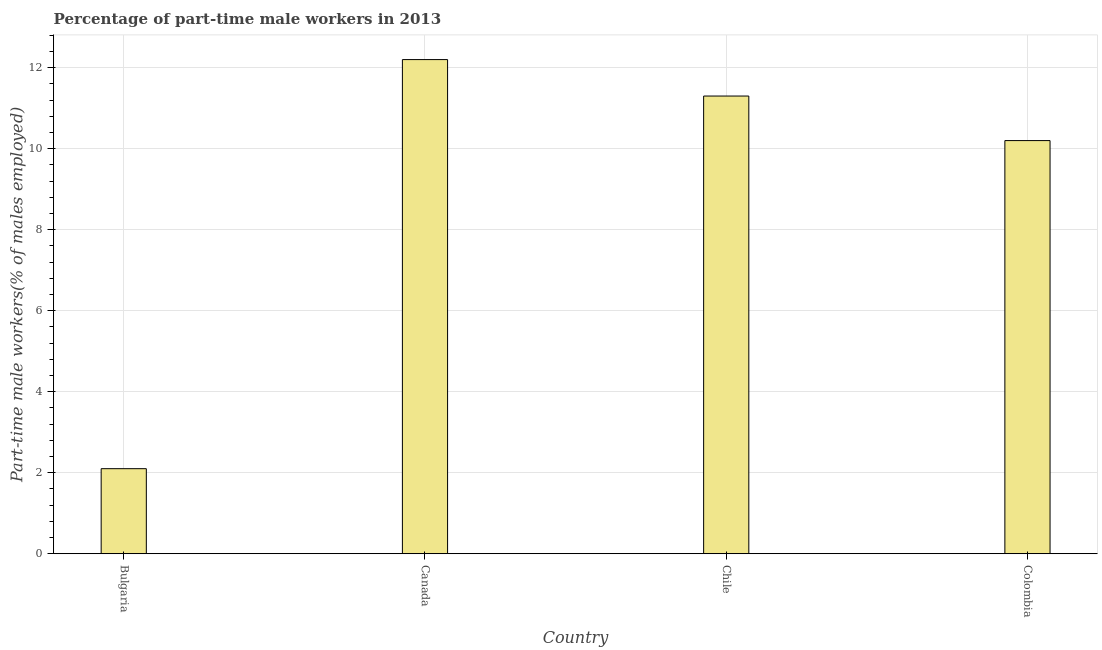What is the title of the graph?
Offer a terse response. Percentage of part-time male workers in 2013. What is the label or title of the Y-axis?
Offer a terse response. Part-time male workers(% of males employed). What is the percentage of part-time male workers in Colombia?
Give a very brief answer. 10.2. Across all countries, what is the maximum percentage of part-time male workers?
Give a very brief answer. 12.2. Across all countries, what is the minimum percentage of part-time male workers?
Provide a short and direct response. 2.1. In which country was the percentage of part-time male workers minimum?
Give a very brief answer. Bulgaria. What is the sum of the percentage of part-time male workers?
Your answer should be compact. 35.8. What is the difference between the percentage of part-time male workers in Bulgaria and Canada?
Provide a succinct answer. -10.1. What is the average percentage of part-time male workers per country?
Your answer should be very brief. 8.95. What is the median percentage of part-time male workers?
Ensure brevity in your answer.  10.75. Is the percentage of part-time male workers in Bulgaria less than that in Canada?
Ensure brevity in your answer.  Yes. What is the difference between the highest and the lowest percentage of part-time male workers?
Your answer should be very brief. 10.1. In how many countries, is the percentage of part-time male workers greater than the average percentage of part-time male workers taken over all countries?
Give a very brief answer. 3. Are all the bars in the graph horizontal?
Make the answer very short. No. How many countries are there in the graph?
Provide a succinct answer. 4. Are the values on the major ticks of Y-axis written in scientific E-notation?
Offer a very short reply. No. What is the Part-time male workers(% of males employed) in Bulgaria?
Your answer should be compact. 2.1. What is the Part-time male workers(% of males employed) of Canada?
Give a very brief answer. 12.2. What is the Part-time male workers(% of males employed) in Chile?
Your answer should be very brief. 11.3. What is the Part-time male workers(% of males employed) of Colombia?
Your response must be concise. 10.2. What is the difference between the Part-time male workers(% of males employed) in Bulgaria and Chile?
Your answer should be compact. -9.2. What is the ratio of the Part-time male workers(% of males employed) in Bulgaria to that in Canada?
Your response must be concise. 0.17. What is the ratio of the Part-time male workers(% of males employed) in Bulgaria to that in Chile?
Ensure brevity in your answer.  0.19. What is the ratio of the Part-time male workers(% of males employed) in Bulgaria to that in Colombia?
Give a very brief answer. 0.21. What is the ratio of the Part-time male workers(% of males employed) in Canada to that in Colombia?
Provide a succinct answer. 1.2. What is the ratio of the Part-time male workers(% of males employed) in Chile to that in Colombia?
Offer a terse response. 1.11. 